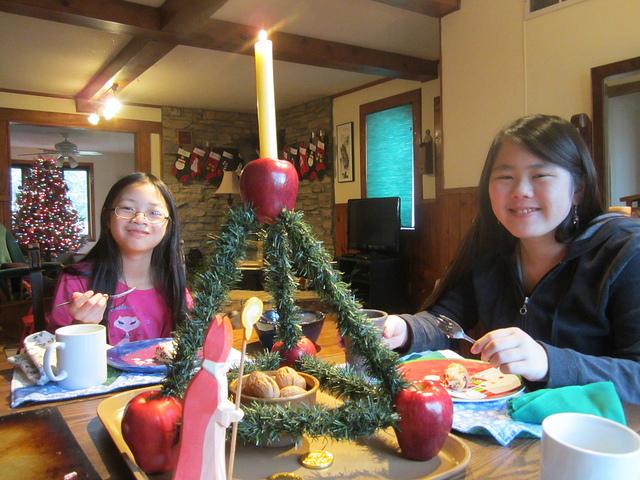What IS the candle holder made out of that is edible?
Give a very brief answer. Apples. Is there a Christmas tree in the picture?
Give a very brief answer. Yes. Are those oranges?
Short answer required. No. 